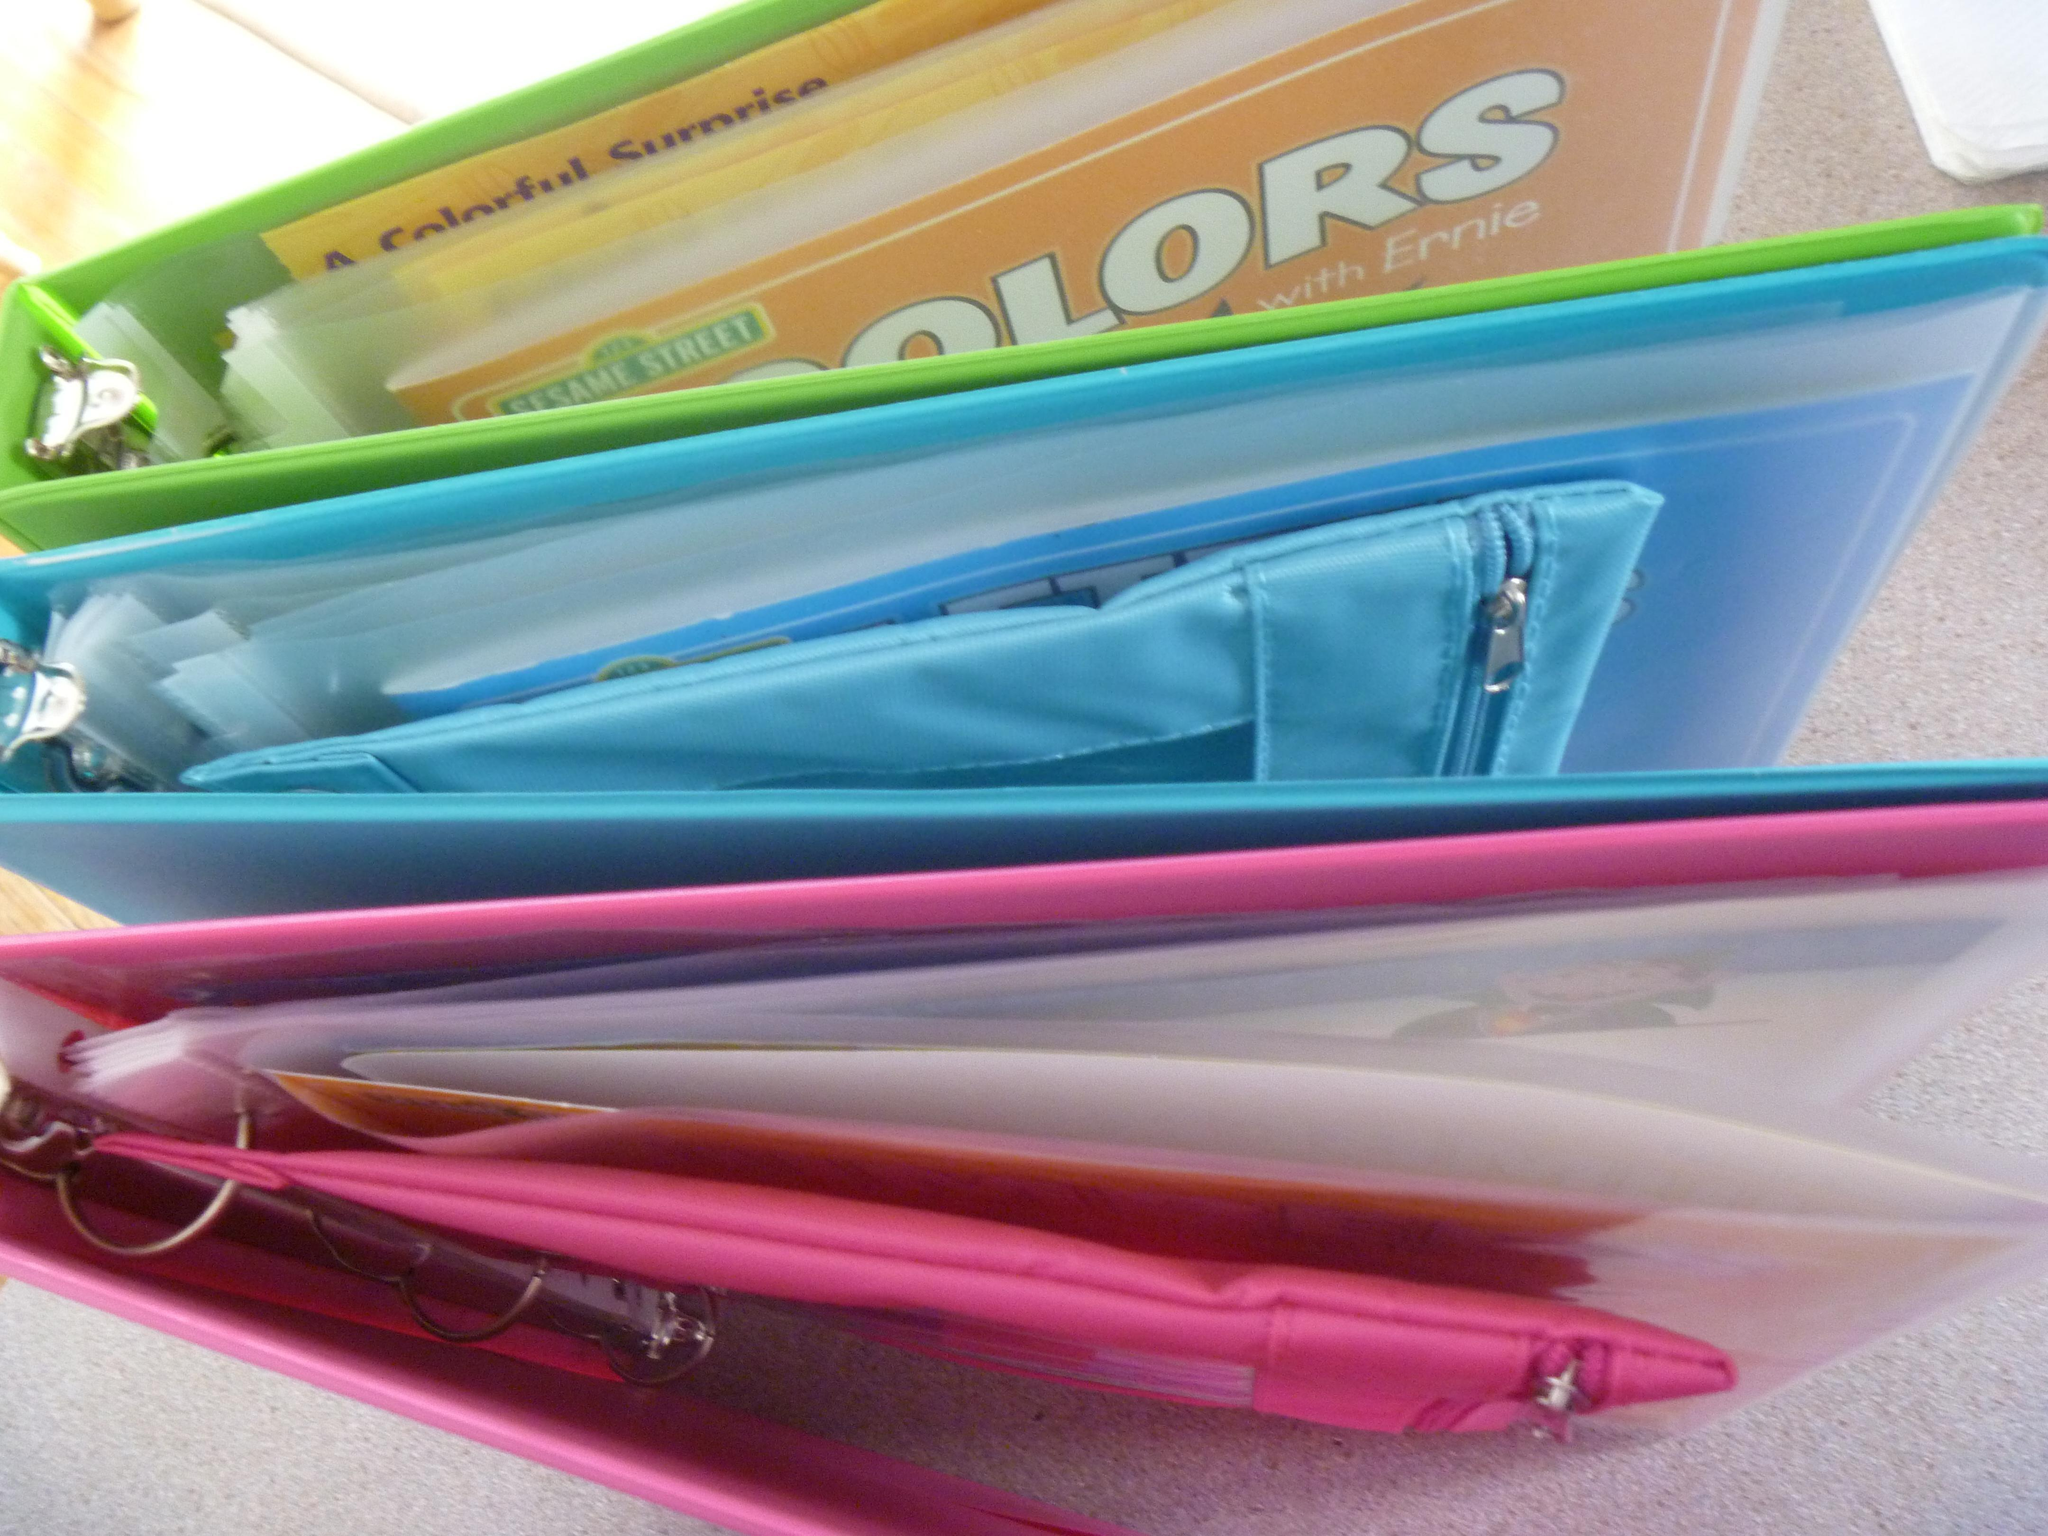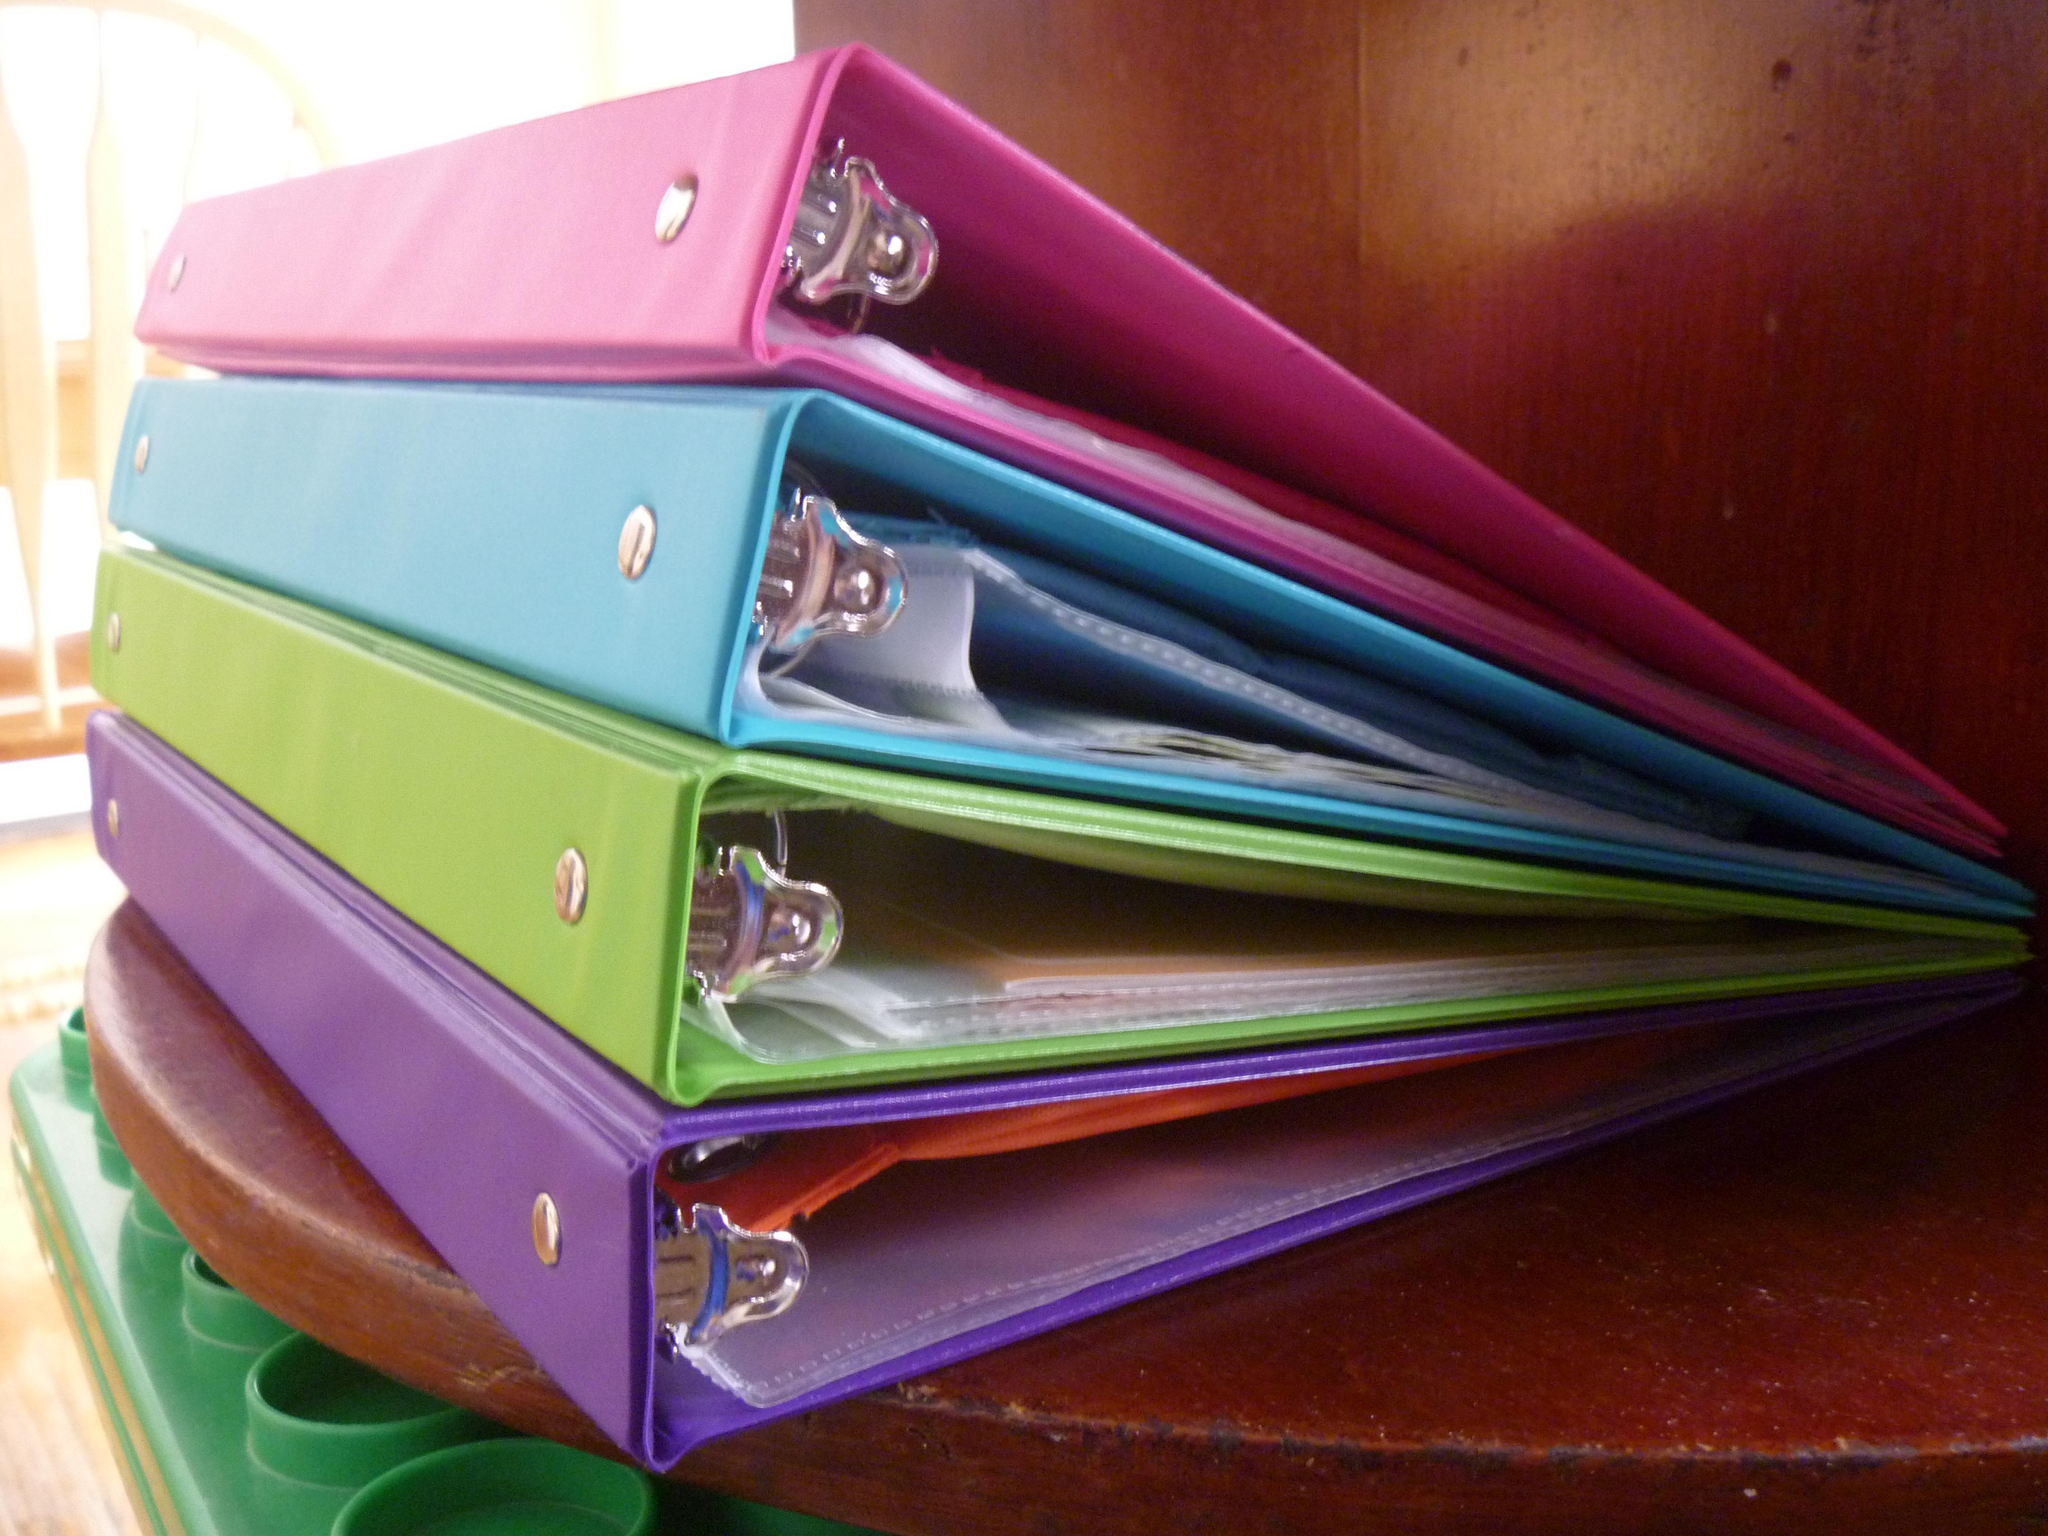The first image is the image on the left, the second image is the image on the right. For the images displayed, is the sentence "There are four binders in the image on the right." factually correct? Answer yes or no. Yes. 